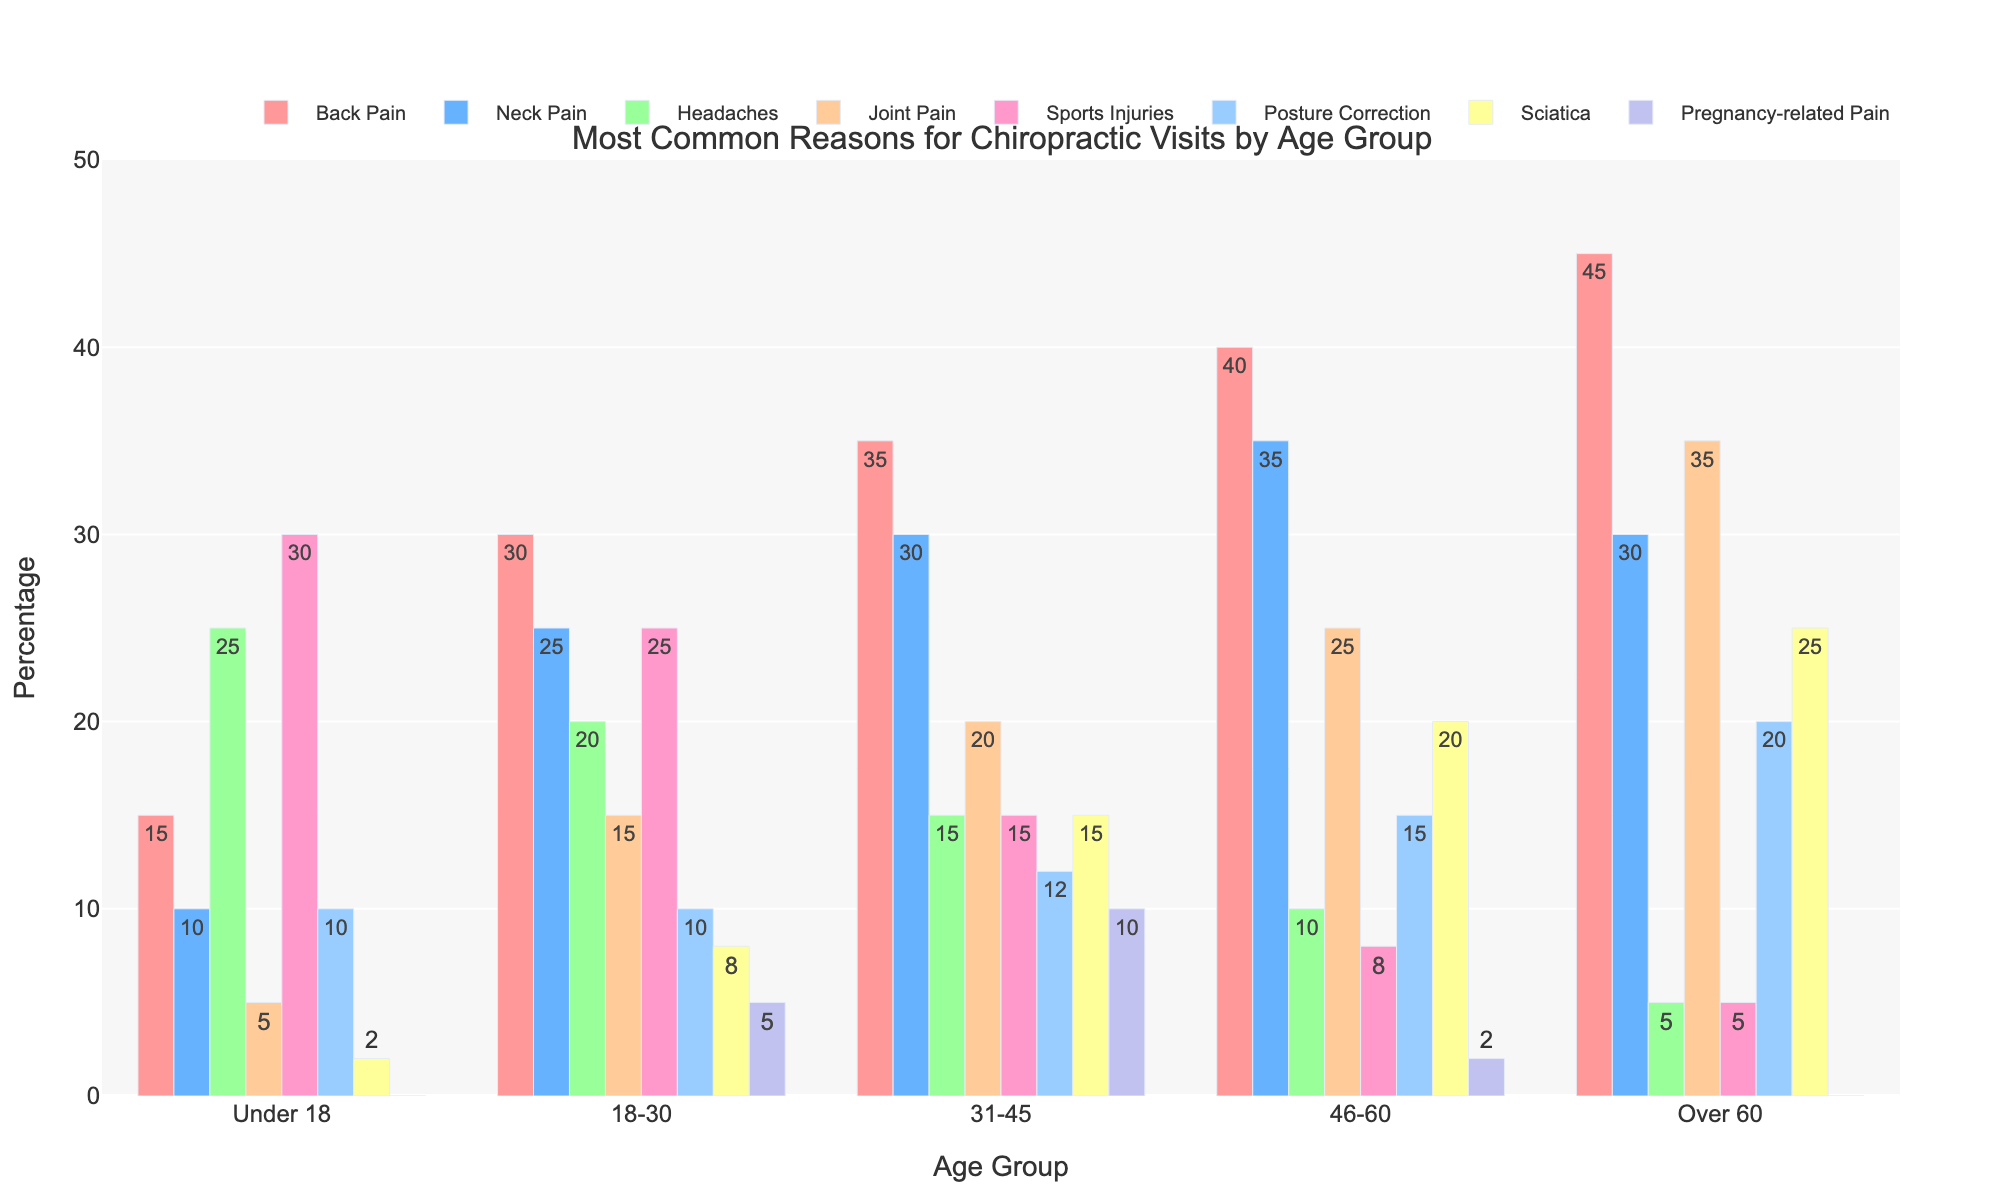What is the most common reason for chiropractic visits among the 46-60 age group? Observe the heights of the bars in the 46-60 age group section, the bar for Back Pain is the tallest.
Answer: Back Pain Which age group has the highest percentage for headaches? Look for the tallest bar in the Headaches category across all age groups. The 25% bar for Under 18 is the tallest.
Answer: Under 18 What is the difference in the percentage of joint pain between the 31-45 and Over 60 age groups? Joint Pain for 31-45 is 20% and for Over 60 is 35%. The difference is 35% - 20% = 15%.
Answer: 15% Which age group has the least percentage of sports injuries? Find the shortest bar in the Sports Injuries category. The Over 60 age group has a bar of 5%.
Answer: Over 60 How does the percentage of neck pain for the 18-30 age group compare to the percentage for the 31-45 age group? Neck Pain is 25% for 18-30 and 30% for 31-45. The 31-45 age group has 5% more.
Answer: 31-45 is higher by 5% For which age group is posture correction most prominent? Identify the tallest bar in the Posture Correction category. The Over 60 age group has a 20% bar.
Answer: Over 60 What is the sum of the percentages for Back Pain and Sciatica in the Over 60 age group? Back Pain is 45% and Sciatica is 25%. Summing them gives 45% + 25% = 70%.
Answer: 70% How does the frequency of pregnancy-related pain vary between Under 18 and 18-30 age groups? For Under 18, the value is 0%. For 18-30, it is 5%. The 18-30 age group has 5% more.
Answer: 18-30 is higher by 5% Which two age groups have an equal percentage for headaches? Headaches for Under 18 is 25% and for 18-30 is 20%. None have equal percentages, so look again; 31-45 has 15%, 46-60 has 10%, Over 60 has 5%. Identify if any are the same.
Answer: None What is the average percentage of neck pain for all age groups? Calculate Neck Pain values and average: (10% + 25% + 30% + 35% + 30%)/5 = 26%.
Answer: 26% 